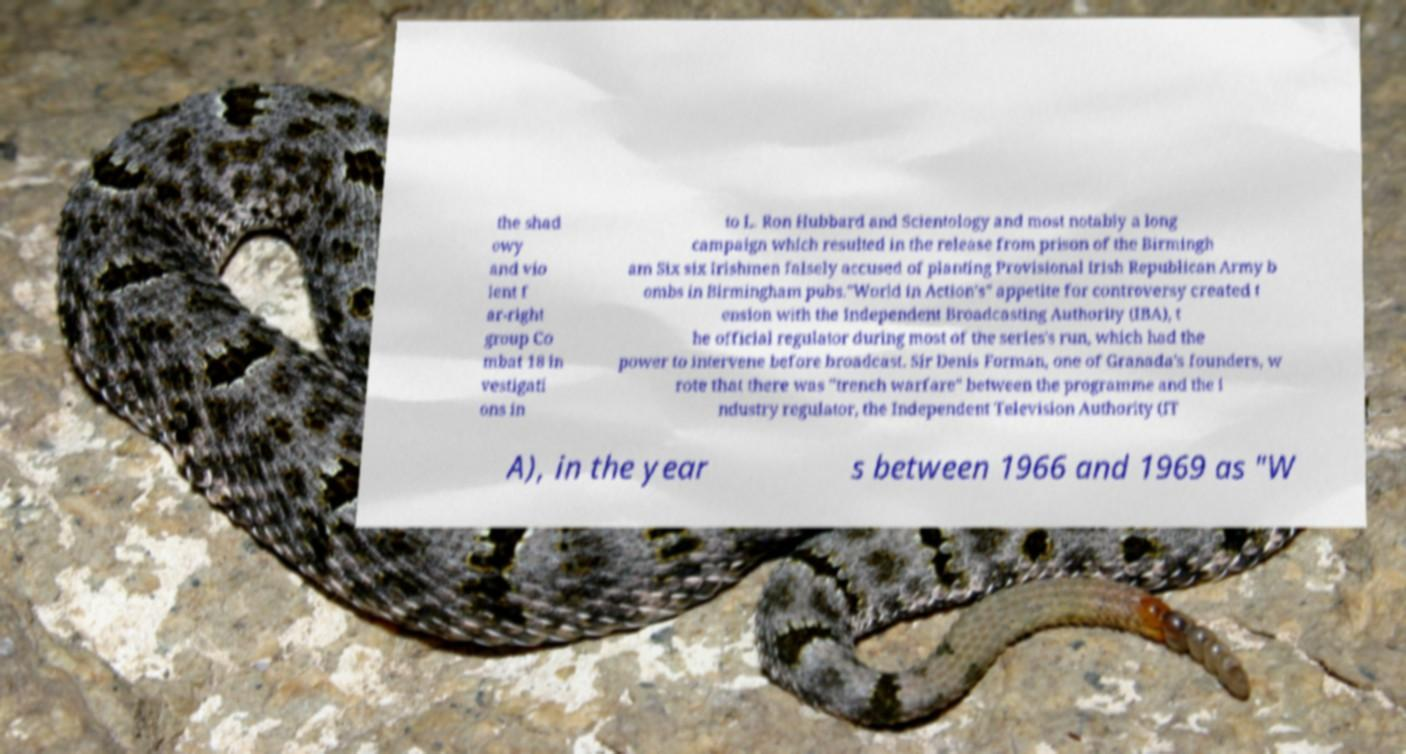For documentation purposes, I need the text within this image transcribed. Could you provide that? the shad owy and vio lent f ar-right group Co mbat 18 in vestigati ons in to L. Ron Hubbard and Scientology and most notably a long campaign which resulted in the release from prison of the Birmingh am Six six Irishmen falsely accused of planting Provisional Irish Republican Army b ombs in Birmingham pubs."World in Action's" appetite for controversy created t ension with the Independent Broadcasting Authority (IBA), t he official regulator during most of the series's run, which had the power to intervene before broadcast. Sir Denis Forman, one of Granada's founders, w rote that there was "trench warfare" between the programme and the i ndustry regulator, the Independent Television Authority (IT A), in the year s between 1966 and 1969 as "W 